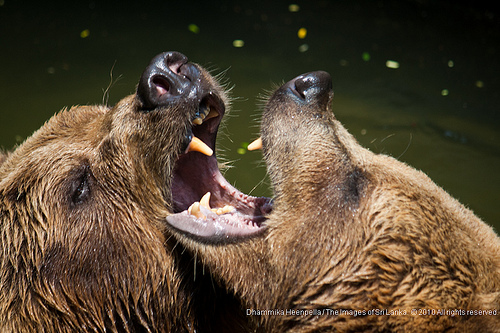<image>
Is the animal on the animal? Yes. Looking at the image, I can see the animal is positioned on top of the animal, with the animal providing support. Where is the teeth in relation to the bear? Is it in the bear? No. The teeth is not contained within the bear. These objects have a different spatial relationship. 